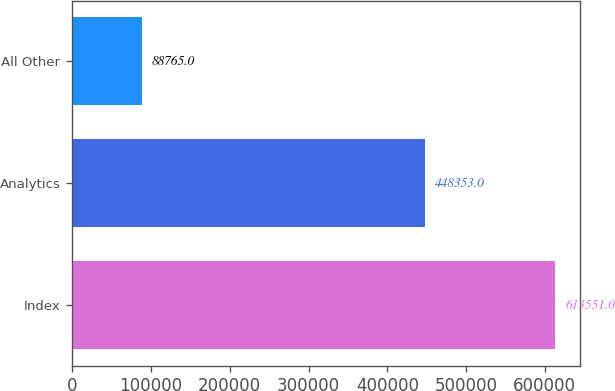<chart> <loc_0><loc_0><loc_500><loc_500><bar_chart><fcel>Index<fcel>Analytics<fcel>All Other<nl><fcel>613551<fcel>448353<fcel>88765<nl></chart> 